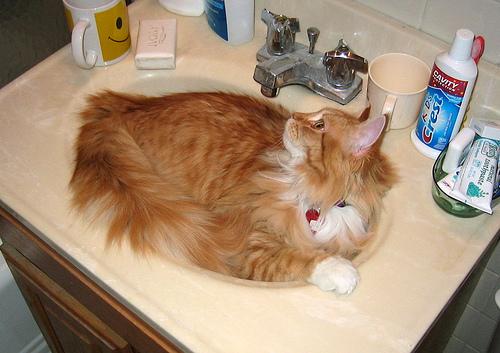What color is the cat?
Give a very brief answer. Orange. What is the brand of toothpaste?
Be succinct. Crest. What brand of toothpaste does the human use?
Short answer required. Crest. What color is the sink?
Short answer required. Tan. 